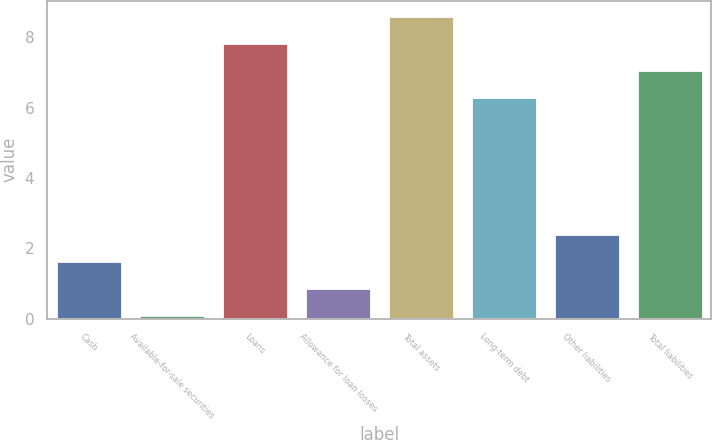Convert chart to OTSL. <chart><loc_0><loc_0><loc_500><loc_500><bar_chart><fcel>Cash<fcel>Available-for-sale securities<fcel>Loans<fcel>Allowance for loan losses<fcel>Total assets<fcel>Long-term debt<fcel>Other liabilities<fcel>Total liabilities<nl><fcel>1.64<fcel>0.1<fcel>7.84<fcel>0.87<fcel>8.61<fcel>6.3<fcel>2.41<fcel>7.07<nl></chart> 